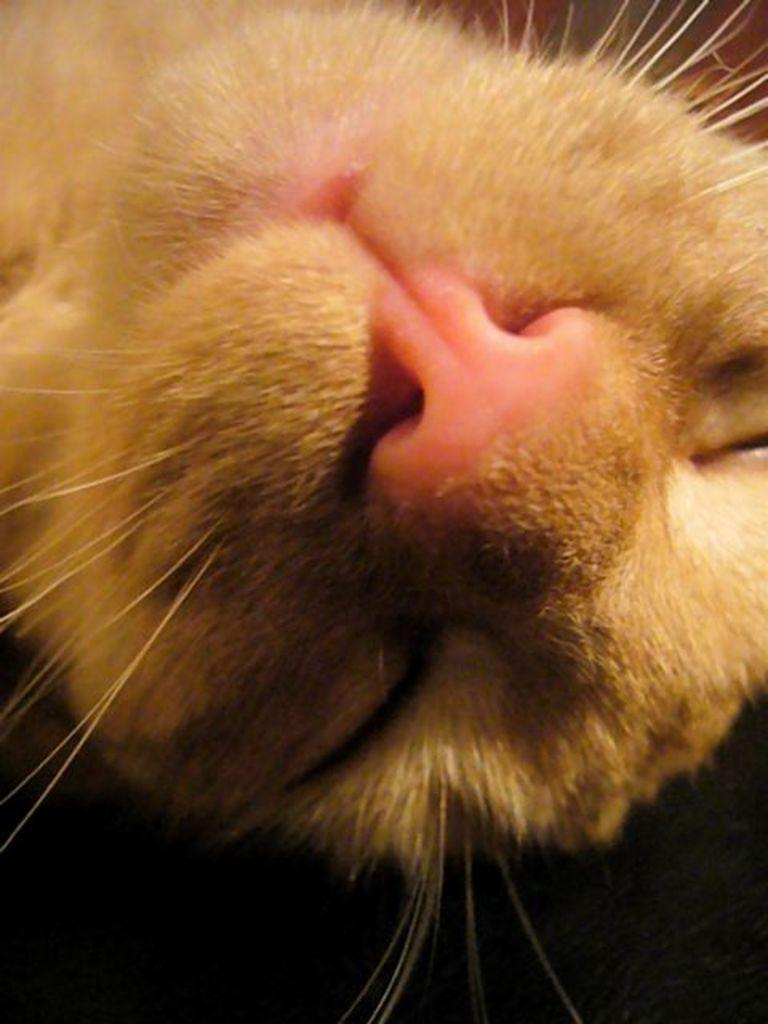What is the main subject in the center of the image? There is a cat face in the center of the image. What type of trip or holiday is the cat going on in the image? There is no indication of a trip or holiday in the image, as it only features a cat face. Is the cat driving a vehicle in the image? There is no cat or vehicle present in the image. 